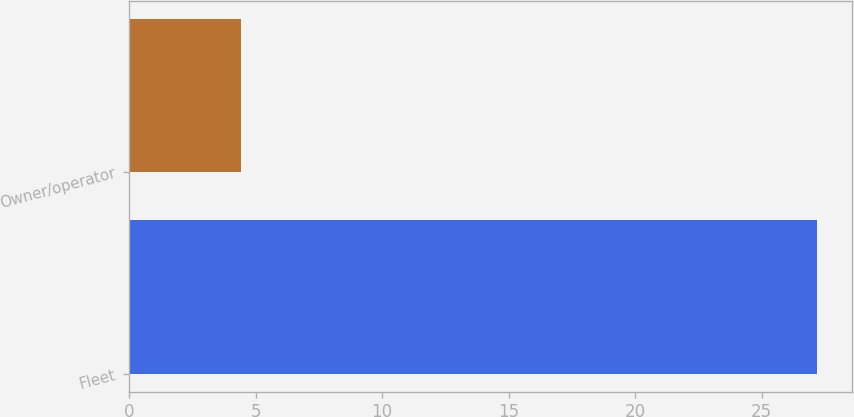<chart> <loc_0><loc_0><loc_500><loc_500><bar_chart><fcel>Fleet<fcel>Owner/operator<nl><fcel>27.2<fcel>4.4<nl></chart> 